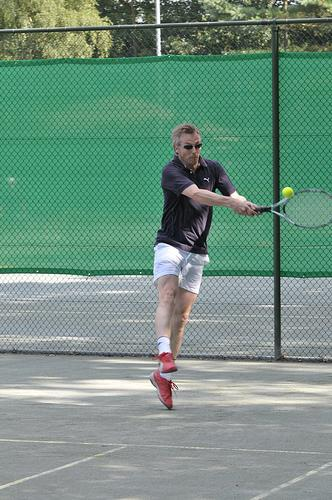Why does the man have his arms out?

Choices:
A) measure
B) break fall
C) to balance
D) to swing to swing 